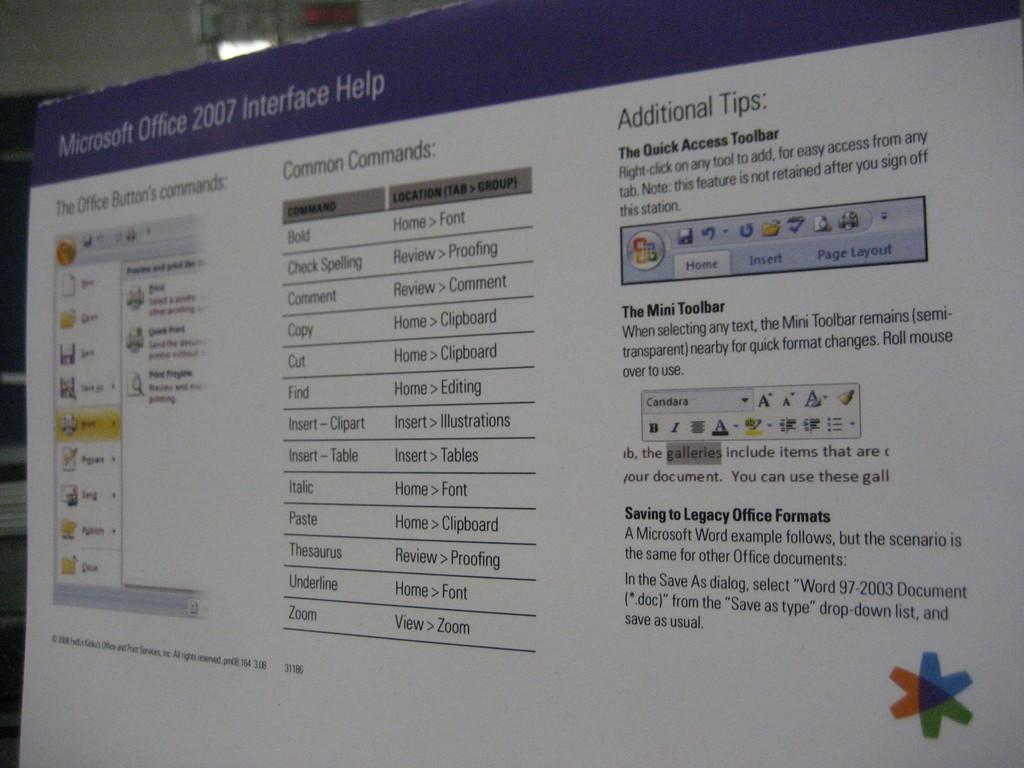<image>
Provide a brief description of the given image. A computer screen showing a page with Microsoft Office 2007 open on it. 